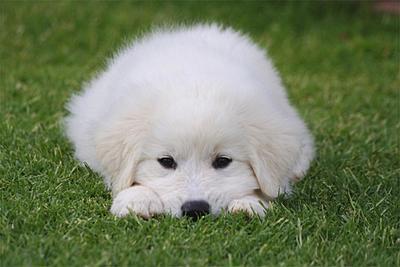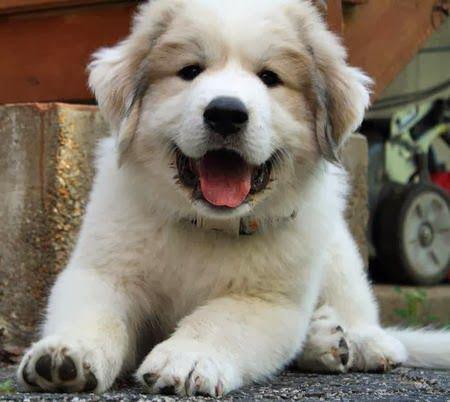The first image is the image on the left, the second image is the image on the right. For the images displayed, is the sentence "The left image shows a white dog in the grass." factually correct? Answer yes or no. Yes. 